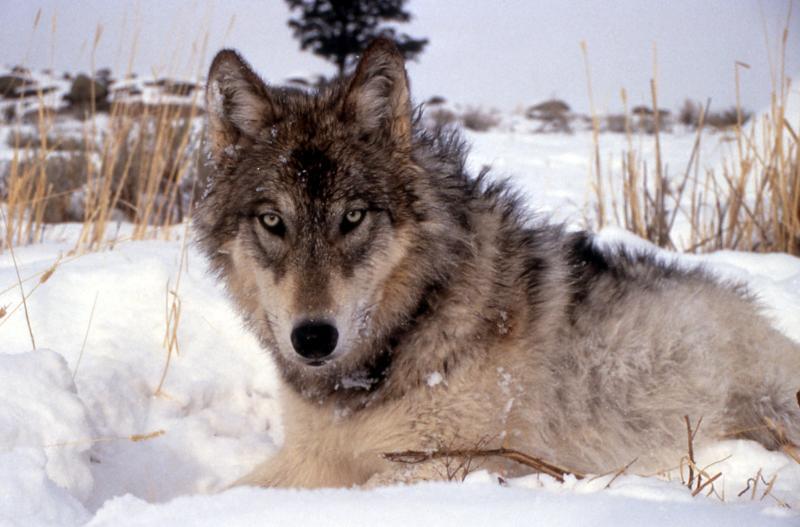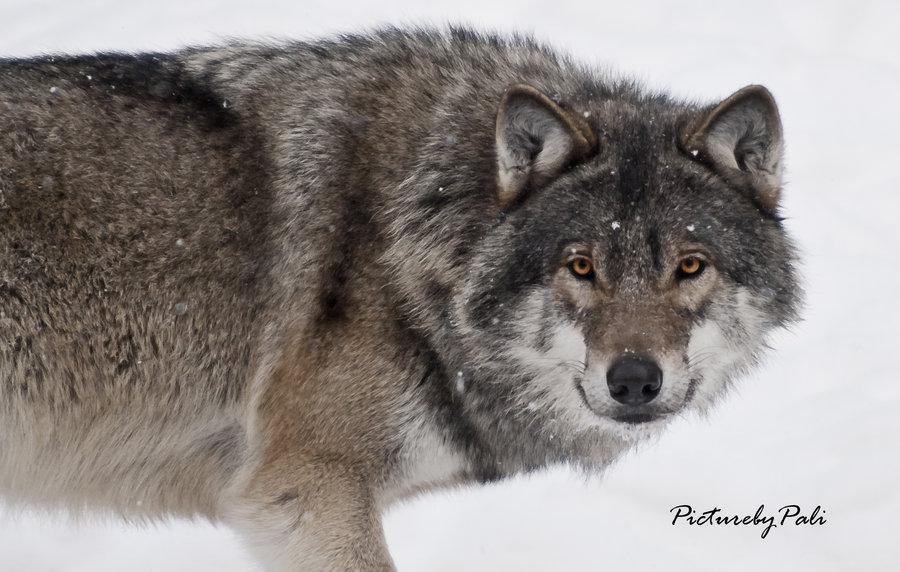The first image is the image on the left, the second image is the image on the right. For the images shown, is this caption "At least one of the animals is walking in the snow." true? Answer yes or no. Yes. The first image is the image on the left, the second image is the image on the right. Assess this claim about the two images: "At least one image shows a wolf in a snowy scene.". Correct or not? Answer yes or no. Yes. 